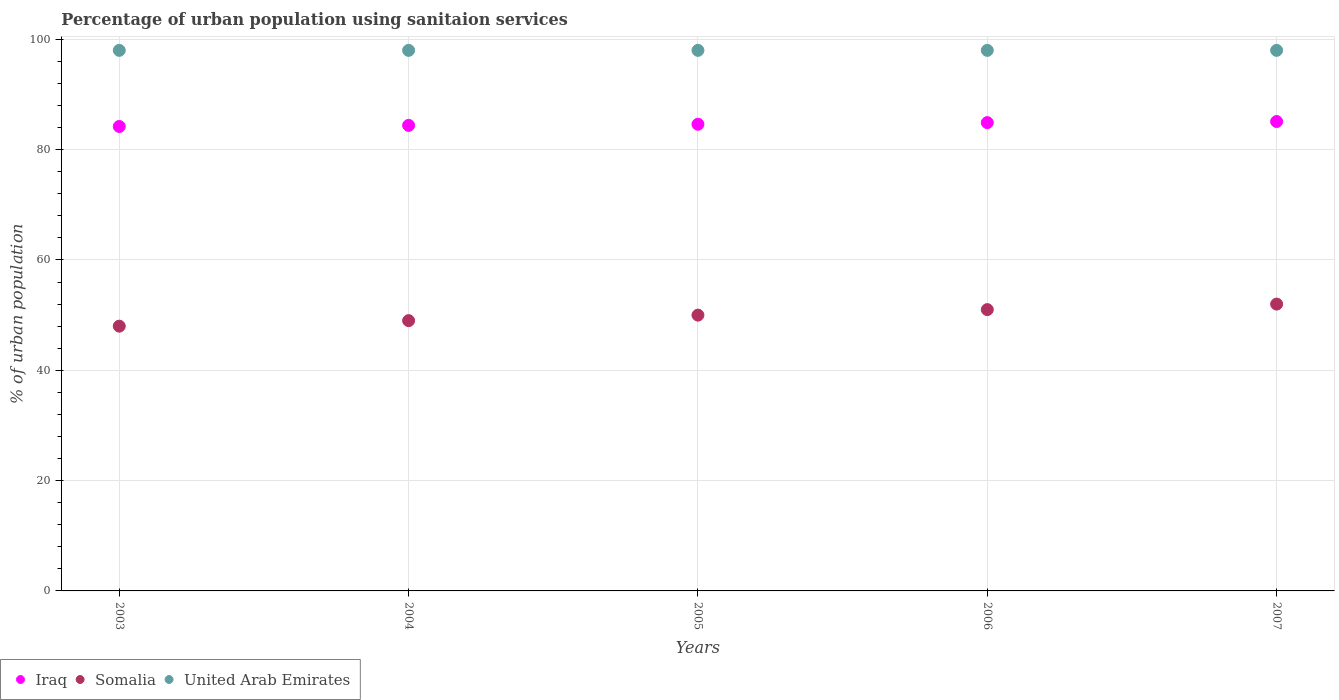How many different coloured dotlines are there?
Provide a succinct answer. 3. Is the number of dotlines equal to the number of legend labels?
Your answer should be very brief. Yes. What is the percentage of urban population using sanitaion services in United Arab Emirates in 2007?
Make the answer very short. 98. Across all years, what is the minimum percentage of urban population using sanitaion services in Somalia?
Make the answer very short. 48. In which year was the percentage of urban population using sanitaion services in Iraq minimum?
Provide a succinct answer. 2003. What is the total percentage of urban population using sanitaion services in Iraq in the graph?
Offer a very short reply. 423.2. What is the difference between the percentage of urban population using sanitaion services in Iraq in 2003 and that in 2006?
Provide a succinct answer. -0.7. What is the difference between the percentage of urban population using sanitaion services in Iraq in 2005 and the percentage of urban population using sanitaion services in Somalia in 2007?
Keep it short and to the point. 32.6. Is the difference between the percentage of urban population using sanitaion services in United Arab Emirates in 2006 and 2007 greater than the difference between the percentage of urban population using sanitaion services in Somalia in 2006 and 2007?
Your answer should be compact. Yes. What is the difference between the highest and the lowest percentage of urban population using sanitaion services in Iraq?
Your response must be concise. 0.9. In how many years, is the percentage of urban population using sanitaion services in Iraq greater than the average percentage of urban population using sanitaion services in Iraq taken over all years?
Your answer should be very brief. 2. Is the sum of the percentage of urban population using sanitaion services in Iraq in 2004 and 2006 greater than the maximum percentage of urban population using sanitaion services in Somalia across all years?
Your response must be concise. Yes. Is the percentage of urban population using sanitaion services in United Arab Emirates strictly greater than the percentage of urban population using sanitaion services in Somalia over the years?
Your answer should be very brief. Yes. What is the difference between two consecutive major ticks on the Y-axis?
Provide a short and direct response. 20. Are the values on the major ticks of Y-axis written in scientific E-notation?
Keep it short and to the point. No. Does the graph contain any zero values?
Provide a short and direct response. No. Does the graph contain grids?
Provide a short and direct response. Yes. Where does the legend appear in the graph?
Ensure brevity in your answer.  Bottom left. What is the title of the graph?
Keep it short and to the point. Percentage of urban population using sanitaion services. What is the label or title of the X-axis?
Your answer should be very brief. Years. What is the label or title of the Y-axis?
Keep it short and to the point. % of urban population. What is the % of urban population in Iraq in 2003?
Keep it short and to the point. 84.2. What is the % of urban population of Iraq in 2004?
Make the answer very short. 84.4. What is the % of urban population of Iraq in 2005?
Make the answer very short. 84.6. What is the % of urban population in Iraq in 2006?
Keep it short and to the point. 84.9. What is the % of urban population in Somalia in 2006?
Ensure brevity in your answer.  51. What is the % of urban population of United Arab Emirates in 2006?
Make the answer very short. 98. What is the % of urban population of Iraq in 2007?
Offer a very short reply. 85.1. Across all years, what is the maximum % of urban population of Iraq?
Your answer should be very brief. 85.1. Across all years, what is the maximum % of urban population in Somalia?
Offer a terse response. 52. Across all years, what is the minimum % of urban population in Iraq?
Your answer should be compact. 84.2. Across all years, what is the minimum % of urban population of Somalia?
Provide a succinct answer. 48. Across all years, what is the minimum % of urban population of United Arab Emirates?
Ensure brevity in your answer.  98. What is the total % of urban population in Iraq in the graph?
Make the answer very short. 423.2. What is the total % of urban population of Somalia in the graph?
Keep it short and to the point. 250. What is the total % of urban population of United Arab Emirates in the graph?
Give a very brief answer. 490. What is the difference between the % of urban population in Iraq in 2003 and that in 2004?
Offer a very short reply. -0.2. What is the difference between the % of urban population in Somalia in 2003 and that in 2004?
Ensure brevity in your answer.  -1. What is the difference between the % of urban population in Iraq in 2003 and that in 2005?
Make the answer very short. -0.4. What is the difference between the % of urban population of Somalia in 2003 and that in 2005?
Offer a very short reply. -2. What is the difference between the % of urban population in United Arab Emirates in 2003 and that in 2006?
Your answer should be compact. 0. What is the difference between the % of urban population in Iraq in 2003 and that in 2007?
Give a very brief answer. -0.9. What is the difference between the % of urban population in Somalia in 2003 and that in 2007?
Provide a short and direct response. -4. What is the difference between the % of urban population in United Arab Emirates in 2003 and that in 2007?
Ensure brevity in your answer.  0. What is the difference between the % of urban population in Somalia in 2004 and that in 2005?
Provide a succinct answer. -1. What is the difference between the % of urban population in Somalia in 2004 and that in 2006?
Ensure brevity in your answer.  -2. What is the difference between the % of urban population of United Arab Emirates in 2004 and that in 2006?
Offer a very short reply. 0. What is the difference between the % of urban population in Iraq in 2004 and that in 2007?
Make the answer very short. -0.7. What is the difference between the % of urban population of Somalia in 2004 and that in 2007?
Ensure brevity in your answer.  -3. What is the difference between the % of urban population of United Arab Emirates in 2004 and that in 2007?
Your answer should be very brief. 0. What is the difference between the % of urban population of Somalia in 2005 and that in 2006?
Give a very brief answer. -1. What is the difference between the % of urban population of United Arab Emirates in 2005 and that in 2006?
Make the answer very short. 0. What is the difference between the % of urban population in Iraq in 2005 and that in 2007?
Offer a terse response. -0.5. What is the difference between the % of urban population of Iraq in 2006 and that in 2007?
Your answer should be compact. -0.2. What is the difference between the % of urban population of United Arab Emirates in 2006 and that in 2007?
Offer a very short reply. 0. What is the difference between the % of urban population in Iraq in 2003 and the % of urban population in Somalia in 2004?
Your response must be concise. 35.2. What is the difference between the % of urban population of Iraq in 2003 and the % of urban population of United Arab Emirates in 2004?
Your response must be concise. -13.8. What is the difference between the % of urban population of Somalia in 2003 and the % of urban population of United Arab Emirates in 2004?
Provide a succinct answer. -50. What is the difference between the % of urban population of Iraq in 2003 and the % of urban population of Somalia in 2005?
Your response must be concise. 34.2. What is the difference between the % of urban population of Iraq in 2003 and the % of urban population of United Arab Emirates in 2005?
Provide a succinct answer. -13.8. What is the difference between the % of urban population of Somalia in 2003 and the % of urban population of United Arab Emirates in 2005?
Your answer should be compact. -50. What is the difference between the % of urban population in Iraq in 2003 and the % of urban population in Somalia in 2006?
Offer a terse response. 33.2. What is the difference between the % of urban population of Iraq in 2003 and the % of urban population of Somalia in 2007?
Offer a very short reply. 32.2. What is the difference between the % of urban population in Iraq in 2003 and the % of urban population in United Arab Emirates in 2007?
Offer a terse response. -13.8. What is the difference between the % of urban population of Somalia in 2003 and the % of urban population of United Arab Emirates in 2007?
Keep it short and to the point. -50. What is the difference between the % of urban population in Iraq in 2004 and the % of urban population in Somalia in 2005?
Provide a succinct answer. 34.4. What is the difference between the % of urban population in Somalia in 2004 and the % of urban population in United Arab Emirates in 2005?
Your response must be concise. -49. What is the difference between the % of urban population in Iraq in 2004 and the % of urban population in Somalia in 2006?
Your answer should be compact. 33.4. What is the difference between the % of urban population of Iraq in 2004 and the % of urban population of United Arab Emirates in 2006?
Your answer should be very brief. -13.6. What is the difference between the % of urban population of Somalia in 2004 and the % of urban population of United Arab Emirates in 2006?
Provide a short and direct response. -49. What is the difference between the % of urban population of Iraq in 2004 and the % of urban population of Somalia in 2007?
Offer a very short reply. 32.4. What is the difference between the % of urban population in Somalia in 2004 and the % of urban population in United Arab Emirates in 2007?
Provide a short and direct response. -49. What is the difference between the % of urban population in Iraq in 2005 and the % of urban population in Somalia in 2006?
Keep it short and to the point. 33.6. What is the difference between the % of urban population of Iraq in 2005 and the % of urban population of United Arab Emirates in 2006?
Offer a terse response. -13.4. What is the difference between the % of urban population in Somalia in 2005 and the % of urban population in United Arab Emirates in 2006?
Your response must be concise. -48. What is the difference between the % of urban population of Iraq in 2005 and the % of urban population of Somalia in 2007?
Offer a terse response. 32.6. What is the difference between the % of urban population of Iraq in 2005 and the % of urban population of United Arab Emirates in 2007?
Give a very brief answer. -13.4. What is the difference between the % of urban population of Somalia in 2005 and the % of urban population of United Arab Emirates in 2007?
Ensure brevity in your answer.  -48. What is the difference between the % of urban population of Iraq in 2006 and the % of urban population of Somalia in 2007?
Give a very brief answer. 32.9. What is the difference between the % of urban population of Iraq in 2006 and the % of urban population of United Arab Emirates in 2007?
Offer a terse response. -13.1. What is the difference between the % of urban population of Somalia in 2006 and the % of urban population of United Arab Emirates in 2007?
Ensure brevity in your answer.  -47. What is the average % of urban population in Iraq per year?
Your response must be concise. 84.64. What is the average % of urban population of United Arab Emirates per year?
Keep it short and to the point. 98. In the year 2003, what is the difference between the % of urban population in Iraq and % of urban population in Somalia?
Provide a short and direct response. 36.2. In the year 2003, what is the difference between the % of urban population in Somalia and % of urban population in United Arab Emirates?
Give a very brief answer. -50. In the year 2004, what is the difference between the % of urban population in Iraq and % of urban population in Somalia?
Provide a short and direct response. 35.4. In the year 2004, what is the difference between the % of urban population in Iraq and % of urban population in United Arab Emirates?
Ensure brevity in your answer.  -13.6. In the year 2004, what is the difference between the % of urban population of Somalia and % of urban population of United Arab Emirates?
Your answer should be compact. -49. In the year 2005, what is the difference between the % of urban population of Iraq and % of urban population of Somalia?
Offer a very short reply. 34.6. In the year 2005, what is the difference between the % of urban population of Somalia and % of urban population of United Arab Emirates?
Offer a very short reply. -48. In the year 2006, what is the difference between the % of urban population of Iraq and % of urban population of Somalia?
Offer a terse response. 33.9. In the year 2006, what is the difference between the % of urban population of Iraq and % of urban population of United Arab Emirates?
Offer a very short reply. -13.1. In the year 2006, what is the difference between the % of urban population in Somalia and % of urban population in United Arab Emirates?
Your answer should be compact. -47. In the year 2007, what is the difference between the % of urban population of Iraq and % of urban population of Somalia?
Ensure brevity in your answer.  33.1. In the year 2007, what is the difference between the % of urban population of Somalia and % of urban population of United Arab Emirates?
Provide a succinct answer. -46. What is the ratio of the % of urban population of Iraq in 2003 to that in 2004?
Offer a very short reply. 1. What is the ratio of the % of urban population of Somalia in 2003 to that in 2004?
Your answer should be compact. 0.98. What is the ratio of the % of urban population in Iraq in 2003 to that in 2007?
Offer a very short reply. 0.99. What is the ratio of the % of urban population in Somalia in 2003 to that in 2007?
Keep it short and to the point. 0.92. What is the ratio of the % of urban population in United Arab Emirates in 2003 to that in 2007?
Your response must be concise. 1. What is the ratio of the % of urban population in Somalia in 2004 to that in 2006?
Your answer should be very brief. 0.96. What is the ratio of the % of urban population of United Arab Emirates in 2004 to that in 2006?
Make the answer very short. 1. What is the ratio of the % of urban population of Somalia in 2004 to that in 2007?
Offer a terse response. 0.94. What is the ratio of the % of urban population in Iraq in 2005 to that in 2006?
Your answer should be very brief. 1. What is the ratio of the % of urban population in Somalia in 2005 to that in 2006?
Make the answer very short. 0.98. What is the ratio of the % of urban population of United Arab Emirates in 2005 to that in 2006?
Make the answer very short. 1. What is the ratio of the % of urban population in Somalia in 2005 to that in 2007?
Keep it short and to the point. 0.96. What is the ratio of the % of urban population in Iraq in 2006 to that in 2007?
Provide a succinct answer. 1. What is the ratio of the % of urban population in Somalia in 2006 to that in 2007?
Provide a short and direct response. 0.98. What is the ratio of the % of urban population of United Arab Emirates in 2006 to that in 2007?
Your answer should be compact. 1. What is the difference between the highest and the second highest % of urban population in Iraq?
Give a very brief answer. 0.2. What is the difference between the highest and the second highest % of urban population in Somalia?
Offer a very short reply. 1. What is the difference between the highest and the second highest % of urban population of United Arab Emirates?
Provide a short and direct response. 0. What is the difference between the highest and the lowest % of urban population in Somalia?
Give a very brief answer. 4. 